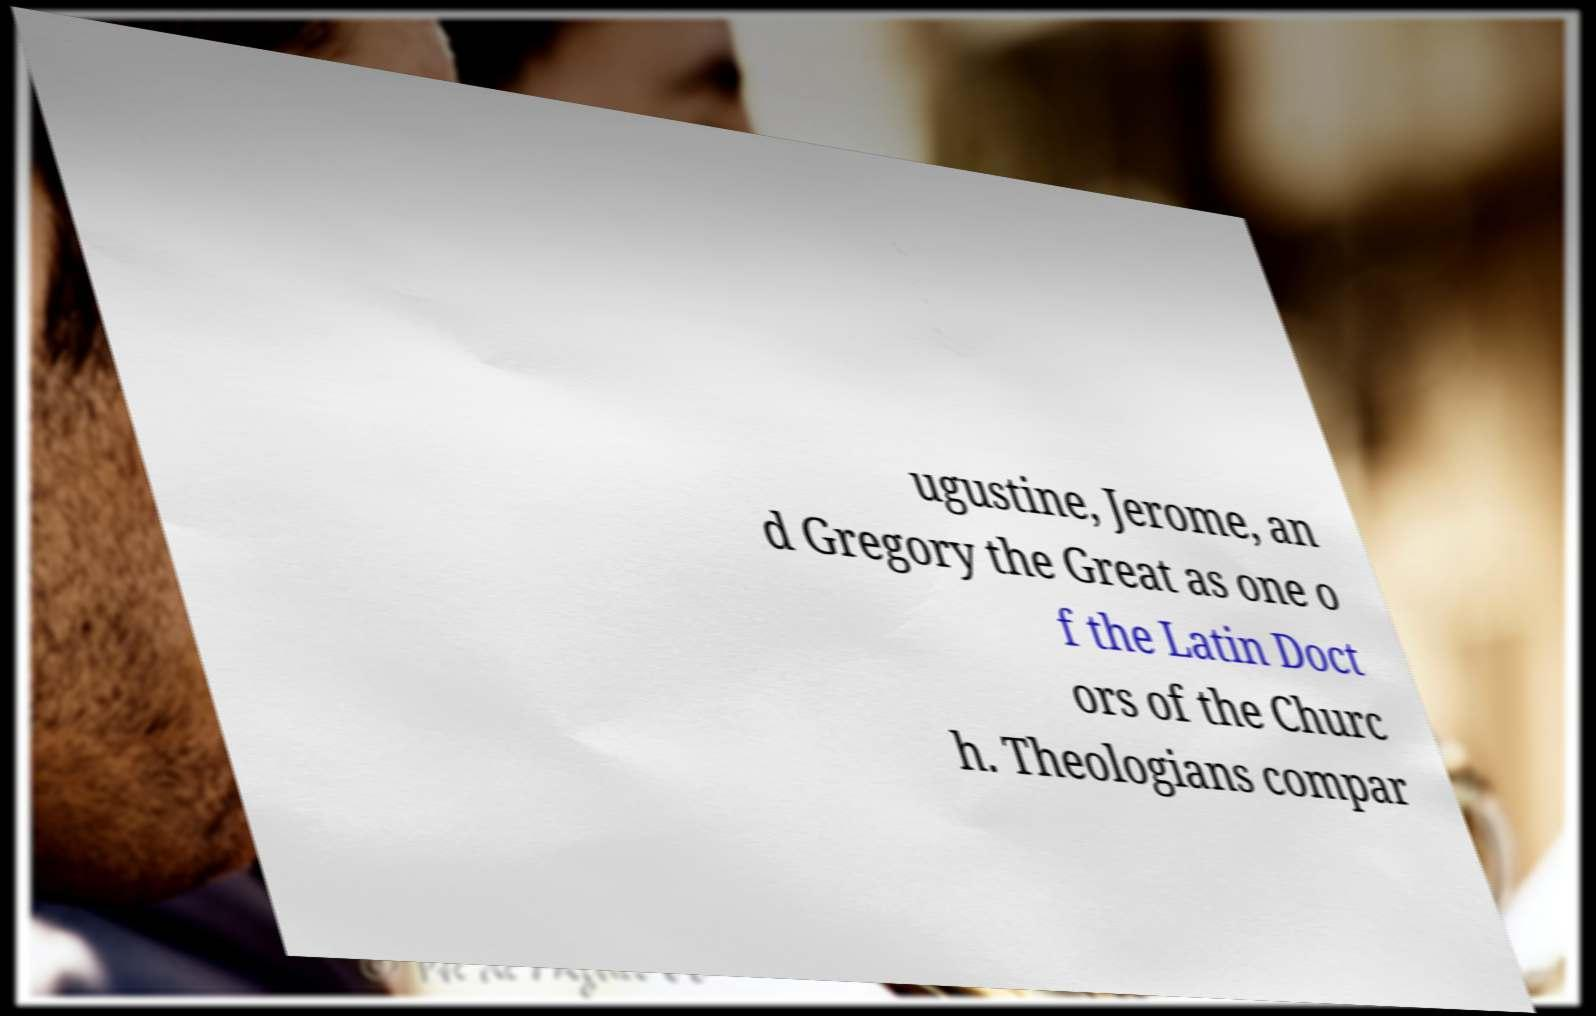Please identify and transcribe the text found in this image. ugustine, Jerome, an d Gregory the Great as one o f the Latin Doct ors of the Churc h. Theologians compar 